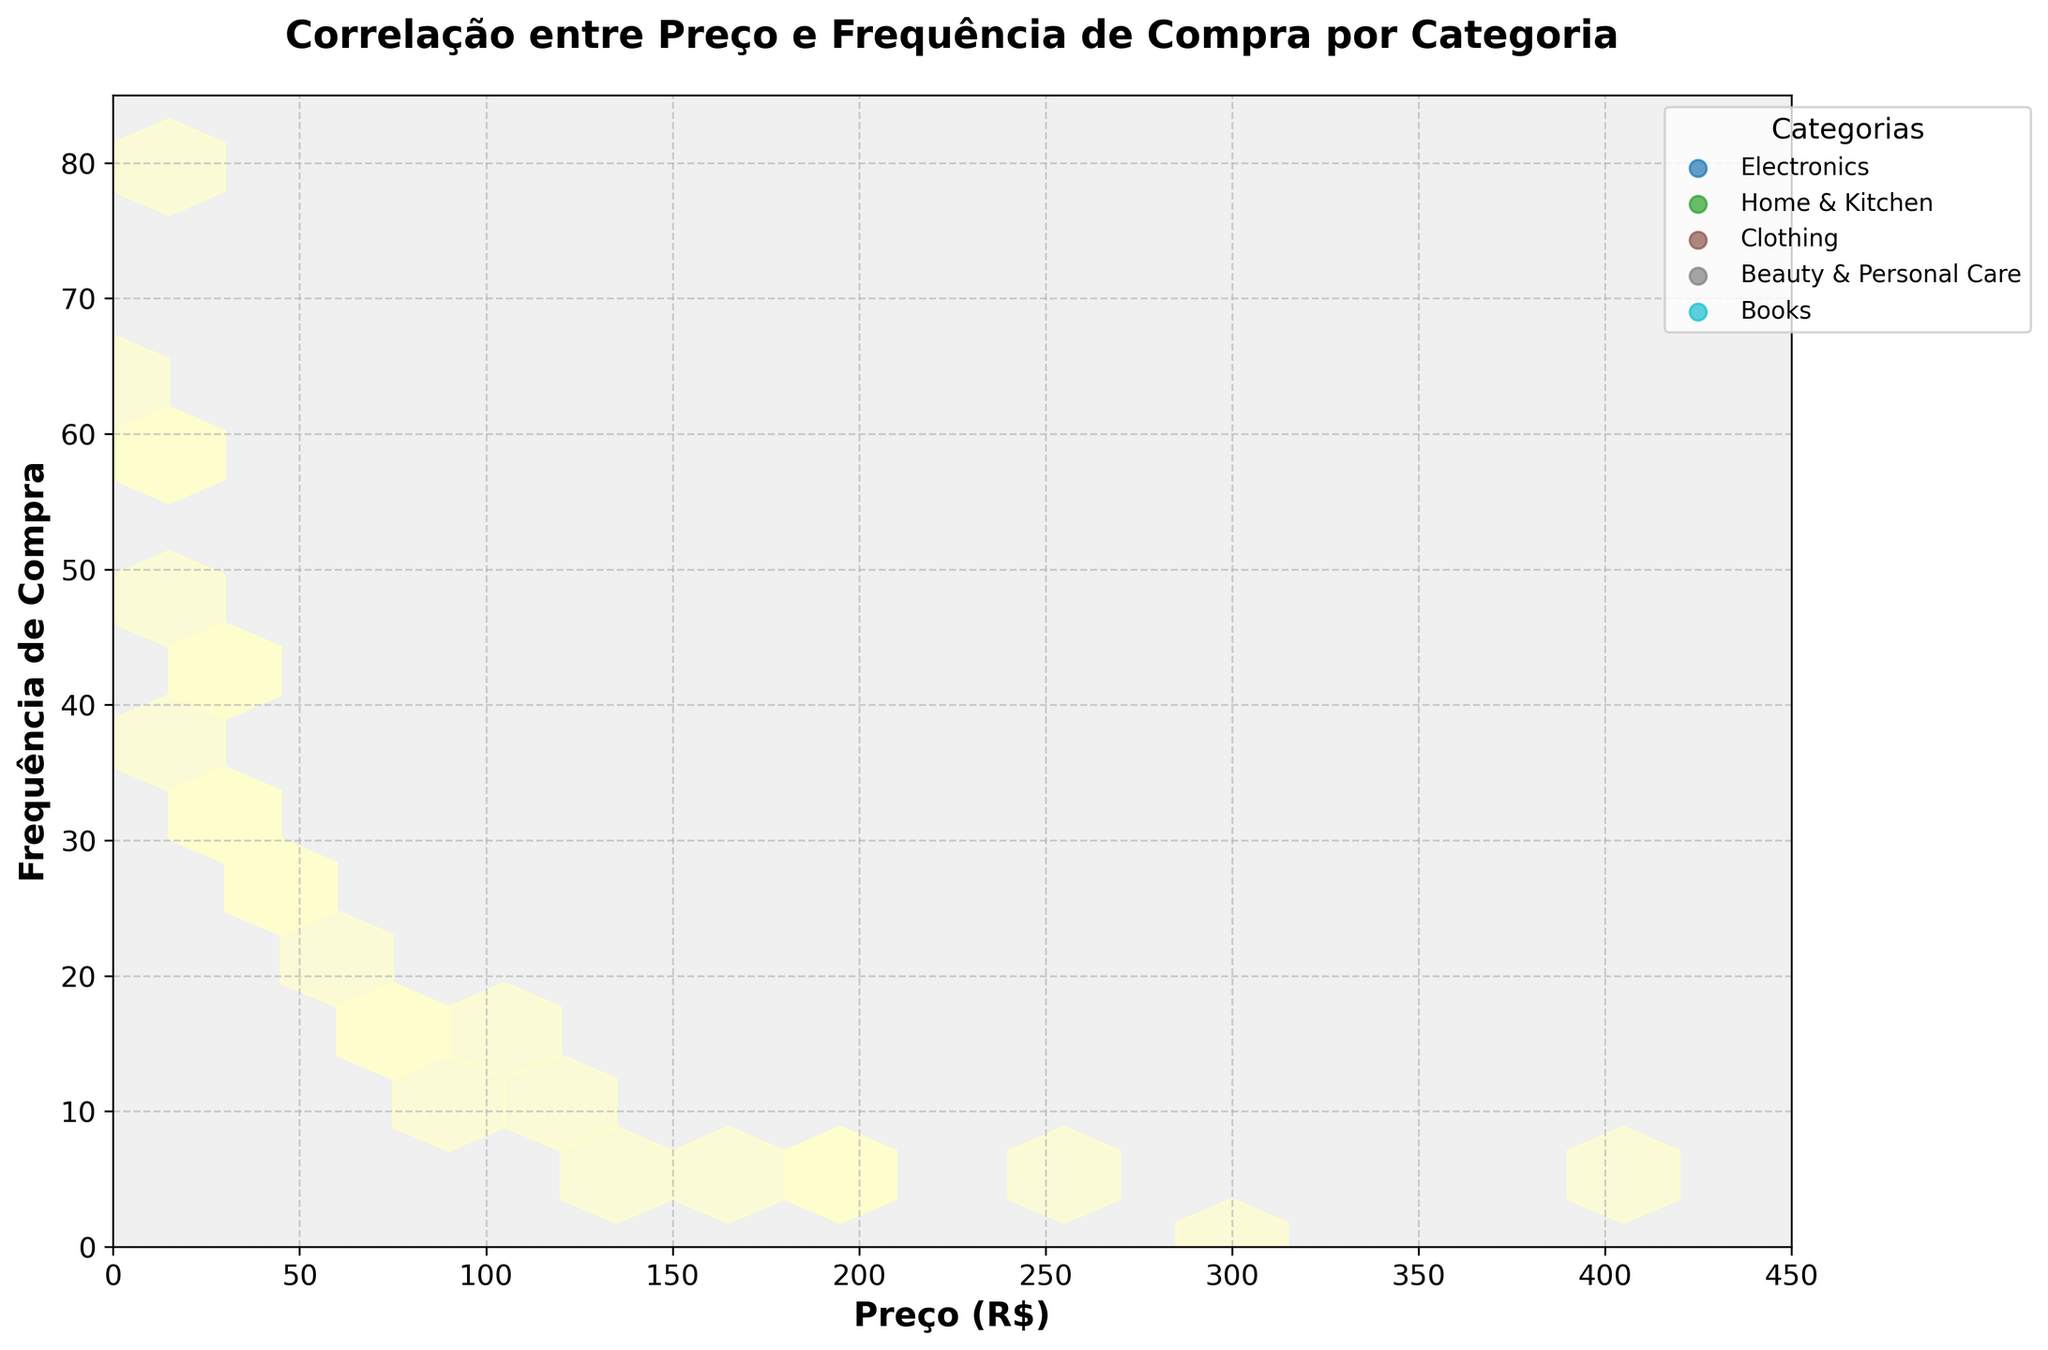What is the title of the hexbin plot? The title of the hexbin plot is usually written at the top of the figure and provides an overview of what the plot represents. In this case, by checking the code, we can see that the title is set to "Correlação entre Preço e Frequência de Compra por Categoria"
Answer: Correlação entre Preço e Frequência de Compra por Categoria Which category has the highest purchase frequency at the lowest price point? The category with the highest purchase frequency can be found by looking at the color density at the lowest price range. We see that Beauty & Personal Care has a high frequency (80 purchases) at the lowest price point (7.99).
Answer: Beauty & Personal Care What is the relationship between price and purchase frequency for the Electronics category? The relationship can be derived by looking at the data points' distribution for Electronics. As the price increases, the purchase frequency tends to decrease (more dense hexagons at lower prices and frequency thins out at higher prices).
Answer: Negative correlation Which category has the highest concentration of purchases in mid-price ranges (around R$30 to R$70)? To determine this, we examine the density of hexagons in the mid-price range. Categories with more dense hexagons around R$30 to R$70 are likely to have higher concentrations. All categories have some activity, but Home & Kitchen and Clothing appear to have particularly high densities.
Answer: Home & Kitchen and Clothing How do prices above R$150 affect purchase frequency across different categories? Examine hexagons for data points where the price is above R$150. For all categories, purchase frequency is very low at prices above R$150, indicating that higher prices negatively impact purchase frequency.
Answer: Purchase frequency is low Which category shows a significant drop in purchase frequency when prices exceed R$100? By looking at the density of hex bins before and after the R$100 price mark, we can observe that for Books and Clothing categories, there is a notable drop in purchase frequency.
Answer: Books and Clothing What general trend can be seen about the correlation between price and purchase frequency? From the hexbin plot, we can observe that generally, as the price increases, the purchase frequency decreases across all categories. This trend is indicated by the decreasing density of hexagons as prices increase.
Answer: As price increases, purchase frequency decreases Are there any categories whose purchase frequencies remain relatively stable across different price points? By examining the spread of hexagons across the price spectrum for different categories, we can see that none of the categories show a stable purchase frequency; all categories show a decrease as prices increase, especially above R$100.
Answer: No, all categories show a decrease 